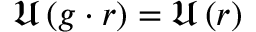Convert formula to latex. <formula><loc_0><loc_0><loc_500><loc_500>\mathfrak { U } \left ( g \cdot r \right ) = \mathfrak { U } \left ( r \right )</formula> 